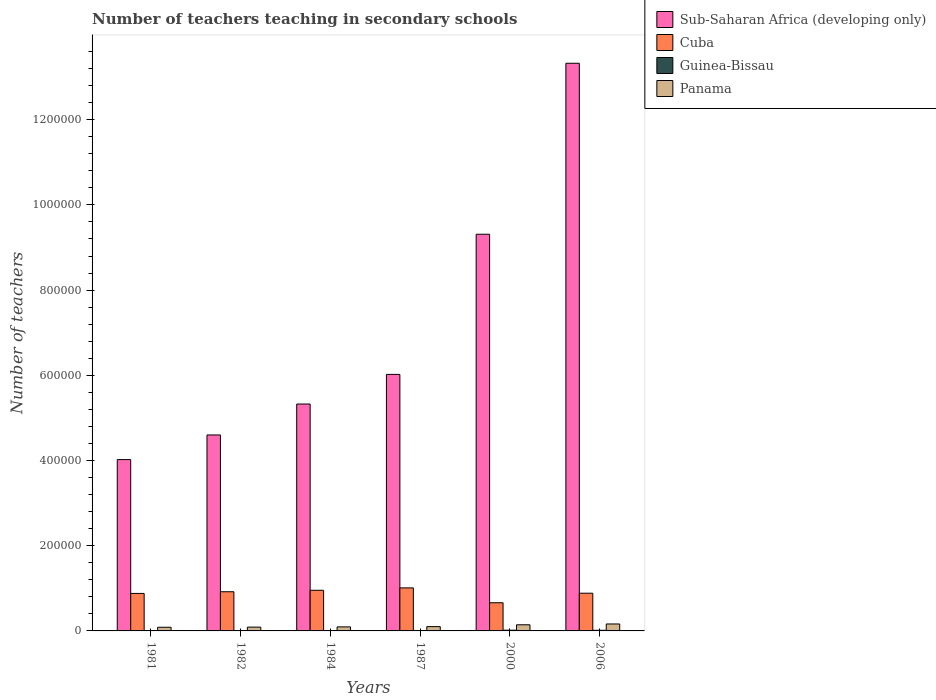How many different coloured bars are there?
Your response must be concise. 4. How many groups of bars are there?
Keep it short and to the point. 6. Are the number of bars on each tick of the X-axis equal?
Offer a terse response. Yes. How many bars are there on the 2nd tick from the left?
Ensure brevity in your answer.  4. In how many cases, is the number of bars for a given year not equal to the number of legend labels?
Ensure brevity in your answer.  0. What is the number of teachers teaching in secondary schools in Sub-Saharan Africa (developing only) in 1984?
Provide a succinct answer. 5.33e+05. Across all years, what is the maximum number of teachers teaching in secondary schools in Sub-Saharan Africa (developing only)?
Ensure brevity in your answer.  1.33e+06. Across all years, what is the minimum number of teachers teaching in secondary schools in Sub-Saharan Africa (developing only)?
Your answer should be very brief. 4.02e+05. What is the total number of teachers teaching in secondary schools in Sub-Saharan Africa (developing only) in the graph?
Provide a short and direct response. 4.26e+06. What is the difference between the number of teachers teaching in secondary schools in Guinea-Bissau in 1987 and that in 2000?
Provide a succinct answer. -953. What is the difference between the number of teachers teaching in secondary schools in Guinea-Bissau in 1981 and the number of teachers teaching in secondary schools in Cuba in 2000?
Your response must be concise. -6.57e+04. What is the average number of teachers teaching in secondary schools in Panama per year?
Your answer should be very brief. 1.13e+04. In the year 2000, what is the difference between the number of teachers teaching in secondary schools in Panama and number of teachers teaching in secondary schools in Guinea-Bissau?
Offer a very short reply. 1.27e+04. What is the ratio of the number of teachers teaching in secondary schools in Cuba in 1981 to that in 2000?
Make the answer very short. 1.33. What is the difference between the highest and the second highest number of teachers teaching in secondary schools in Sub-Saharan Africa (developing only)?
Offer a terse response. 4.01e+05. What is the difference between the highest and the lowest number of teachers teaching in secondary schools in Guinea-Bissau?
Make the answer very short. 1255. In how many years, is the number of teachers teaching in secondary schools in Sub-Saharan Africa (developing only) greater than the average number of teachers teaching in secondary schools in Sub-Saharan Africa (developing only) taken over all years?
Your response must be concise. 2. What does the 1st bar from the left in 2000 represents?
Provide a succinct answer. Sub-Saharan Africa (developing only). What does the 2nd bar from the right in 1982 represents?
Ensure brevity in your answer.  Guinea-Bissau. How many bars are there?
Ensure brevity in your answer.  24. Are all the bars in the graph horizontal?
Provide a short and direct response. No. How many years are there in the graph?
Provide a short and direct response. 6. Are the values on the major ticks of Y-axis written in scientific E-notation?
Offer a very short reply. No. Does the graph contain any zero values?
Provide a succinct answer. No. What is the title of the graph?
Your answer should be very brief. Number of teachers teaching in secondary schools. What is the label or title of the Y-axis?
Offer a very short reply. Number of teachers. What is the Number of teachers in Sub-Saharan Africa (developing only) in 1981?
Your answer should be very brief. 4.02e+05. What is the Number of teachers in Cuba in 1981?
Your answer should be very brief. 8.80e+04. What is the Number of teachers of Guinea-Bissau in 1981?
Offer a terse response. 462. What is the Number of teachers of Panama in 1981?
Give a very brief answer. 8610. What is the Number of teachers of Sub-Saharan Africa (developing only) in 1982?
Your answer should be compact. 4.60e+05. What is the Number of teachers in Cuba in 1982?
Make the answer very short. 9.20e+04. What is the Number of teachers of Guinea-Bissau in 1982?
Your answer should be very brief. 465. What is the Number of teachers in Panama in 1982?
Your response must be concise. 8924. What is the Number of teachers of Sub-Saharan Africa (developing only) in 1984?
Your answer should be very brief. 5.33e+05. What is the Number of teachers of Cuba in 1984?
Your answer should be very brief. 9.54e+04. What is the Number of teachers in Guinea-Bissau in 1984?
Your answer should be very brief. 795. What is the Number of teachers in Panama in 1984?
Give a very brief answer. 9491. What is the Number of teachers in Sub-Saharan Africa (developing only) in 1987?
Your answer should be very brief. 6.02e+05. What is the Number of teachers of Cuba in 1987?
Keep it short and to the point. 1.01e+05. What is the Number of teachers of Guinea-Bissau in 1987?
Ensure brevity in your answer.  764. What is the Number of teachers in Panama in 1987?
Offer a very short reply. 1.01e+04. What is the Number of teachers in Sub-Saharan Africa (developing only) in 2000?
Your answer should be very brief. 9.31e+05. What is the Number of teachers of Cuba in 2000?
Ensure brevity in your answer.  6.61e+04. What is the Number of teachers of Guinea-Bissau in 2000?
Make the answer very short. 1717. What is the Number of teachers in Panama in 2000?
Make the answer very short. 1.44e+04. What is the Number of teachers of Sub-Saharan Africa (developing only) in 2006?
Offer a terse response. 1.33e+06. What is the Number of teachers in Cuba in 2006?
Offer a terse response. 8.85e+04. What is the Number of teachers in Guinea-Bissau in 2006?
Your answer should be compact. 1480. What is the Number of teachers in Panama in 2006?
Your answer should be compact. 1.63e+04. Across all years, what is the maximum Number of teachers in Sub-Saharan Africa (developing only)?
Your answer should be very brief. 1.33e+06. Across all years, what is the maximum Number of teachers of Cuba?
Provide a short and direct response. 1.01e+05. Across all years, what is the maximum Number of teachers in Guinea-Bissau?
Your answer should be compact. 1717. Across all years, what is the maximum Number of teachers of Panama?
Ensure brevity in your answer.  1.63e+04. Across all years, what is the minimum Number of teachers in Sub-Saharan Africa (developing only)?
Offer a terse response. 4.02e+05. Across all years, what is the minimum Number of teachers of Cuba?
Your answer should be compact. 6.61e+04. Across all years, what is the minimum Number of teachers in Guinea-Bissau?
Your answer should be very brief. 462. Across all years, what is the minimum Number of teachers of Panama?
Give a very brief answer. 8610. What is the total Number of teachers of Sub-Saharan Africa (developing only) in the graph?
Offer a very short reply. 4.26e+06. What is the total Number of teachers of Cuba in the graph?
Provide a short and direct response. 5.31e+05. What is the total Number of teachers of Guinea-Bissau in the graph?
Offer a very short reply. 5683. What is the total Number of teachers in Panama in the graph?
Offer a very short reply. 6.78e+04. What is the difference between the Number of teachers in Sub-Saharan Africa (developing only) in 1981 and that in 1982?
Offer a terse response. -5.78e+04. What is the difference between the Number of teachers of Cuba in 1981 and that in 1982?
Keep it short and to the point. -3943. What is the difference between the Number of teachers of Guinea-Bissau in 1981 and that in 1982?
Ensure brevity in your answer.  -3. What is the difference between the Number of teachers of Panama in 1981 and that in 1982?
Offer a terse response. -314. What is the difference between the Number of teachers in Sub-Saharan Africa (developing only) in 1981 and that in 1984?
Make the answer very short. -1.30e+05. What is the difference between the Number of teachers of Cuba in 1981 and that in 1984?
Provide a short and direct response. -7377. What is the difference between the Number of teachers in Guinea-Bissau in 1981 and that in 1984?
Your answer should be compact. -333. What is the difference between the Number of teachers in Panama in 1981 and that in 1984?
Ensure brevity in your answer.  -881. What is the difference between the Number of teachers of Sub-Saharan Africa (developing only) in 1981 and that in 1987?
Make the answer very short. -2.00e+05. What is the difference between the Number of teachers in Cuba in 1981 and that in 1987?
Your response must be concise. -1.30e+04. What is the difference between the Number of teachers of Guinea-Bissau in 1981 and that in 1987?
Your answer should be very brief. -302. What is the difference between the Number of teachers of Panama in 1981 and that in 1987?
Your answer should be very brief. -1458. What is the difference between the Number of teachers of Sub-Saharan Africa (developing only) in 1981 and that in 2000?
Ensure brevity in your answer.  -5.29e+05. What is the difference between the Number of teachers in Cuba in 1981 and that in 2000?
Your response must be concise. 2.19e+04. What is the difference between the Number of teachers of Guinea-Bissau in 1981 and that in 2000?
Your response must be concise. -1255. What is the difference between the Number of teachers of Panama in 1981 and that in 2000?
Your answer should be compact. -5794. What is the difference between the Number of teachers of Sub-Saharan Africa (developing only) in 1981 and that in 2006?
Provide a short and direct response. -9.30e+05. What is the difference between the Number of teachers of Cuba in 1981 and that in 2006?
Your answer should be compact. -519. What is the difference between the Number of teachers in Guinea-Bissau in 1981 and that in 2006?
Offer a very short reply. -1018. What is the difference between the Number of teachers in Panama in 1981 and that in 2006?
Give a very brief answer. -7707. What is the difference between the Number of teachers in Sub-Saharan Africa (developing only) in 1982 and that in 1984?
Provide a succinct answer. -7.27e+04. What is the difference between the Number of teachers in Cuba in 1982 and that in 1984?
Keep it short and to the point. -3434. What is the difference between the Number of teachers in Guinea-Bissau in 1982 and that in 1984?
Your response must be concise. -330. What is the difference between the Number of teachers of Panama in 1982 and that in 1984?
Provide a short and direct response. -567. What is the difference between the Number of teachers in Sub-Saharan Africa (developing only) in 1982 and that in 1987?
Keep it short and to the point. -1.42e+05. What is the difference between the Number of teachers in Cuba in 1982 and that in 1987?
Keep it short and to the point. -9062. What is the difference between the Number of teachers in Guinea-Bissau in 1982 and that in 1987?
Offer a terse response. -299. What is the difference between the Number of teachers in Panama in 1982 and that in 1987?
Your response must be concise. -1144. What is the difference between the Number of teachers in Sub-Saharan Africa (developing only) in 1982 and that in 2000?
Your answer should be very brief. -4.71e+05. What is the difference between the Number of teachers in Cuba in 1982 and that in 2000?
Your answer should be very brief. 2.58e+04. What is the difference between the Number of teachers in Guinea-Bissau in 1982 and that in 2000?
Keep it short and to the point. -1252. What is the difference between the Number of teachers in Panama in 1982 and that in 2000?
Provide a succinct answer. -5480. What is the difference between the Number of teachers of Sub-Saharan Africa (developing only) in 1982 and that in 2006?
Provide a short and direct response. -8.73e+05. What is the difference between the Number of teachers in Cuba in 1982 and that in 2006?
Ensure brevity in your answer.  3424. What is the difference between the Number of teachers in Guinea-Bissau in 1982 and that in 2006?
Make the answer very short. -1015. What is the difference between the Number of teachers of Panama in 1982 and that in 2006?
Your answer should be compact. -7393. What is the difference between the Number of teachers of Sub-Saharan Africa (developing only) in 1984 and that in 1987?
Give a very brief answer. -6.95e+04. What is the difference between the Number of teachers in Cuba in 1984 and that in 1987?
Keep it short and to the point. -5628. What is the difference between the Number of teachers of Guinea-Bissau in 1984 and that in 1987?
Offer a very short reply. 31. What is the difference between the Number of teachers of Panama in 1984 and that in 1987?
Give a very brief answer. -577. What is the difference between the Number of teachers of Sub-Saharan Africa (developing only) in 1984 and that in 2000?
Your answer should be very brief. -3.99e+05. What is the difference between the Number of teachers of Cuba in 1984 and that in 2000?
Your answer should be compact. 2.93e+04. What is the difference between the Number of teachers of Guinea-Bissau in 1984 and that in 2000?
Keep it short and to the point. -922. What is the difference between the Number of teachers in Panama in 1984 and that in 2000?
Your answer should be compact. -4913. What is the difference between the Number of teachers of Sub-Saharan Africa (developing only) in 1984 and that in 2006?
Your response must be concise. -8.00e+05. What is the difference between the Number of teachers of Cuba in 1984 and that in 2006?
Your answer should be compact. 6858. What is the difference between the Number of teachers in Guinea-Bissau in 1984 and that in 2006?
Keep it short and to the point. -685. What is the difference between the Number of teachers in Panama in 1984 and that in 2006?
Your answer should be very brief. -6826. What is the difference between the Number of teachers of Sub-Saharan Africa (developing only) in 1987 and that in 2000?
Give a very brief answer. -3.29e+05. What is the difference between the Number of teachers of Cuba in 1987 and that in 2000?
Offer a terse response. 3.49e+04. What is the difference between the Number of teachers in Guinea-Bissau in 1987 and that in 2000?
Keep it short and to the point. -953. What is the difference between the Number of teachers of Panama in 1987 and that in 2000?
Give a very brief answer. -4336. What is the difference between the Number of teachers in Sub-Saharan Africa (developing only) in 1987 and that in 2006?
Ensure brevity in your answer.  -7.30e+05. What is the difference between the Number of teachers of Cuba in 1987 and that in 2006?
Give a very brief answer. 1.25e+04. What is the difference between the Number of teachers in Guinea-Bissau in 1987 and that in 2006?
Provide a short and direct response. -716. What is the difference between the Number of teachers in Panama in 1987 and that in 2006?
Your response must be concise. -6249. What is the difference between the Number of teachers of Sub-Saharan Africa (developing only) in 2000 and that in 2006?
Ensure brevity in your answer.  -4.01e+05. What is the difference between the Number of teachers of Cuba in 2000 and that in 2006?
Your answer should be compact. -2.24e+04. What is the difference between the Number of teachers of Guinea-Bissau in 2000 and that in 2006?
Make the answer very short. 237. What is the difference between the Number of teachers of Panama in 2000 and that in 2006?
Keep it short and to the point. -1913. What is the difference between the Number of teachers of Sub-Saharan Africa (developing only) in 1981 and the Number of teachers of Cuba in 1982?
Your response must be concise. 3.10e+05. What is the difference between the Number of teachers in Sub-Saharan Africa (developing only) in 1981 and the Number of teachers in Guinea-Bissau in 1982?
Your answer should be very brief. 4.02e+05. What is the difference between the Number of teachers in Sub-Saharan Africa (developing only) in 1981 and the Number of teachers in Panama in 1982?
Offer a terse response. 3.93e+05. What is the difference between the Number of teachers of Cuba in 1981 and the Number of teachers of Guinea-Bissau in 1982?
Ensure brevity in your answer.  8.76e+04. What is the difference between the Number of teachers in Cuba in 1981 and the Number of teachers in Panama in 1982?
Give a very brief answer. 7.91e+04. What is the difference between the Number of teachers in Guinea-Bissau in 1981 and the Number of teachers in Panama in 1982?
Offer a very short reply. -8462. What is the difference between the Number of teachers of Sub-Saharan Africa (developing only) in 1981 and the Number of teachers of Cuba in 1984?
Offer a terse response. 3.07e+05. What is the difference between the Number of teachers in Sub-Saharan Africa (developing only) in 1981 and the Number of teachers in Guinea-Bissau in 1984?
Your answer should be compact. 4.01e+05. What is the difference between the Number of teachers of Sub-Saharan Africa (developing only) in 1981 and the Number of teachers of Panama in 1984?
Your answer should be compact. 3.93e+05. What is the difference between the Number of teachers of Cuba in 1981 and the Number of teachers of Guinea-Bissau in 1984?
Provide a succinct answer. 8.72e+04. What is the difference between the Number of teachers in Cuba in 1981 and the Number of teachers in Panama in 1984?
Make the answer very short. 7.85e+04. What is the difference between the Number of teachers of Guinea-Bissau in 1981 and the Number of teachers of Panama in 1984?
Your answer should be compact. -9029. What is the difference between the Number of teachers in Sub-Saharan Africa (developing only) in 1981 and the Number of teachers in Cuba in 1987?
Your response must be concise. 3.01e+05. What is the difference between the Number of teachers of Sub-Saharan Africa (developing only) in 1981 and the Number of teachers of Guinea-Bissau in 1987?
Offer a terse response. 4.01e+05. What is the difference between the Number of teachers of Sub-Saharan Africa (developing only) in 1981 and the Number of teachers of Panama in 1987?
Provide a succinct answer. 3.92e+05. What is the difference between the Number of teachers in Cuba in 1981 and the Number of teachers in Guinea-Bissau in 1987?
Ensure brevity in your answer.  8.73e+04. What is the difference between the Number of teachers of Cuba in 1981 and the Number of teachers of Panama in 1987?
Make the answer very short. 7.79e+04. What is the difference between the Number of teachers of Guinea-Bissau in 1981 and the Number of teachers of Panama in 1987?
Make the answer very short. -9606. What is the difference between the Number of teachers in Sub-Saharan Africa (developing only) in 1981 and the Number of teachers in Cuba in 2000?
Your response must be concise. 3.36e+05. What is the difference between the Number of teachers of Sub-Saharan Africa (developing only) in 1981 and the Number of teachers of Guinea-Bissau in 2000?
Ensure brevity in your answer.  4.00e+05. What is the difference between the Number of teachers in Sub-Saharan Africa (developing only) in 1981 and the Number of teachers in Panama in 2000?
Provide a succinct answer. 3.88e+05. What is the difference between the Number of teachers in Cuba in 1981 and the Number of teachers in Guinea-Bissau in 2000?
Make the answer very short. 8.63e+04. What is the difference between the Number of teachers in Cuba in 1981 and the Number of teachers in Panama in 2000?
Make the answer very short. 7.36e+04. What is the difference between the Number of teachers in Guinea-Bissau in 1981 and the Number of teachers in Panama in 2000?
Give a very brief answer. -1.39e+04. What is the difference between the Number of teachers of Sub-Saharan Africa (developing only) in 1981 and the Number of teachers of Cuba in 2006?
Give a very brief answer. 3.14e+05. What is the difference between the Number of teachers in Sub-Saharan Africa (developing only) in 1981 and the Number of teachers in Guinea-Bissau in 2006?
Ensure brevity in your answer.  4.01e+05. What is the difference between the Number of teachers in Sub-Saharan Africa (developing only) in 1981 and the Number of teachers in Panama in 2006?
Ensure brevity in your answer.  3.86e+05. What is the difference between the Number of teachers of Cuba in 1981 and the Number of teachers of Guinea-Bissau in 2006?
Your answer should be very brief. 8.65e+04. What is the difference between the Number of teachers of Cuba in 1981 and the Number of teachers of Panama in 2006?
Your response must be concise. 7.17e+04. What is the difference between the Number of teachers of Guinea-Bissau in 1981 and the Number of teachers of Panama in 2006?
Offer a very short reply. -1.59e+04. What is the difference between the Number of teachers in Sub-Saharan Africa (developing only) in 1982 and the Number of teachers in Cuba in 1984?
Make the answer very short. 3.65e+05. What is the difference between the Number of teachers of Sub-Saharan Africa (developing only) in 1982 and the Number of teachers of Guinea-Bissau in 1984?
Offer a very short reply. 4.59e+05. What is the difference between the Number of teachers in Sub-Saharan Africa (developing only) in 1982 and the Number of teachers in Panama in 1984?
Offer a terse response. 4.50e+05. What is the difference between the Number of teachers in Cuba in 1982 and the Number of teachers in Guinea-Bissau in 1984?
Ensure brevity in your answer.  9.12e+04. What is the difference between the Number of teachers in Cuba in 1982 and the Number of teachers in Panama in 1984?
Offer a terse response. 8.25e+04. What is the difference between the Number of teachers of Guinea-Bissau in 1982 and the Number of teachers of Panama in 1984?
Give a very brief answer. -9026. What is the difference between the Number of teachers of Sub-Saharan Africa (developing only) in 1982 and the Number of teachers of Cuba in 1987?
Provide a short and direct response. 3.59e+05. What is the difference between the Number of teachers of Sub-Saharan Africa (developing only) in 1982 and the Number of teachers of Guinea-Bissau in 1987?
Your response must be concise. 4.59e+05. What is the difference between the Number of teachers of Sub-Saharan Africa (developing only) in 1982 and the Number of teachers of Panama in 1987?
Provide a short and direct response. 4.50e+05. What is the difference between the Number of teachers in Cuba in 1982 and the Number of teachers in Guinea-Bissau in 1987?
Your answer should be very brief. 9.12e+04. What is the difference between the Number of teachers of Cuba in 1982 and the Number of teachers of Panama in 1987?
Your answer should be very brief. 8.19e+04. What is the difference between the Number of teachers of Guinea-Bissau in 1982 and the Number of teachers of Panama in 1987?
Offer a terse response. -9603. What is the difference between the Number of teachers of Sub-Saharan Africa (developing only) in 1982 and the Number of teachers of Cuba in 2000?
Your response must be concise. 3.94e+05. What is the difference between the Number of teachers in Sub-Saharan Africa (developing only) in 1982 and the Number of teachers in Guinea-Bissau in 2000?
Provide a succinct answer. 4.58e+05. What is the difference between the Number of teachers in Sub-Saharan Africa (developing only) in 1982 and the Number of teachers in Panama in 2000?
Your answer should be very brief. 4.46e+05. What is the difference between the Number of teachers in Cuba in 1982 and the Number of teachers in Guinea-Bissau in 2000?
Your response must be concise. 9.02e+04. What is the difference between the Number of teachers in Cuba in 1982 and the Number of teachers in Panama in 2000?
Keep it short and to the point. 7.76e+04. What is the difference between the Number of teachers in Guinea-Bissau in 1982 and the Number of teachers in Panama in 2000?
Provide a succinct answer. -1.39e+04. What is the difference between the Number of teachers of Sub-Saharan Africa (developing only) in 1982 and the Number of teachers of Cuba in 2006?
Your response must be concise. 3.71e+05. What is the difference between the Number of teachers of Sub-Saharan Africa (developing only) in 1982 and the Number of teachers of Guinea-Bissau in 2006?
Provide a succinct answer. 4.58e+05. What is the difference between the Number of teachers of Sub-Saharan Africa (developing only) in 1982 and the Number of teachers of Panama in 2006?
Keep it short and to the point. 4.44e+05. What is the difference between the Number of teachers in Cuba in 1982 and the Number of teachers in Guinea-Bissau in 2006?
Ensure brevity in your answer.  9.05e+04. What is the difference between the Number of teachers of Cuba in 1982 and the Number of teachers of Panama in 2006?
Give a very brief answer. 7.56e+04. What is the difference between the Number of teachers in Guinea-Bissau in 1982 and the Number of teachers in Panama in 2006?
Your answer should be compact. -1.59e+04. What is the difference between the Number of teachers in Sub-Saharan Africa (developing only) in 1984 and the Number of teachers in Cuba in 1987?
Offer a terse response. 4.32e+05. What is the difference between the Number of teachers of Sub-Saharan Africa (developing only) in 1984 and the Number of teachers of Guinea-Bissau in 1987?
Your response must be concise. 5.32e+05. What is the difference between the Number of teachers of Sub-Saharan Africa (developing only) in 1984 and the Number of teachers of Panama in 1987?
Offer a terse response. 5.23e+05. What is the difference between the Number of teachers in Cuba in 1984 and the Number of teachers in Guinea-Bissau in 1987?
Keep it short and to the point. 9.46e+04. What is the difference between the Number of teachers in Cuba in 1984 and the Number of teachers in Panama in 1987?
Your answer should be very brief. 8.53e+04. What is the difference between the Number of teachers of Guinea-Bissau in 1984 and the Number of teachers of Panama in 1987?
Your answer should be very brief. -9273. What is the difference between the Number of teachers of Sub-Saharan Africa (developing only) in 1984 and the Number of teachers of Cuba in 2000?
Ensure brevity in your answer.  4.66e+05. What is the difference between the Number of teachers of Sub-Saharan Africa (developing only) in 1984 and the Number of teachers of Guinea-Bissau in 2000?
Give a very brief answer. 5.31e+05. What is the difference between the Number of teachers in Sub-Saharan Africa (developing only) in 1984 and the Number of teachers in Panama in 2000?
Provide a short and direct response. 5.18e+05. What is the difference between the Number of teachers of Cuba in 1984 and the Number of teachers of Guinea-Bissau in 2000?
Your answer should be very brief. 9.37e+04. What is the difference between the Number of teachers in Cuba in 1984 and the Number of teachers in Panama in 2000?
Make the answer very short. 8.10e+04. What is the difference between the Number of teachers in Guinea-Bissau in 1984 and the Number of teachers in Panama in 2000?
Keep it short and to the point. -1.36e+04. What is the difference between the Number of teachers in Sub-Saharan Africa (developing only) in 1984 and the Number of teachers in Cuba in 2006?
Make the answer very short. 4.44e+05. What is the difference between the Number of teachers in Sub-Saharan Africa (developing only) in 1984 and the Number of teachers in Guinea-Bissau in 2006?
Your answer should be very brief. 5.31e+05. What is the difference between the Number of teachers in Sub-Saharan Africa (developing only) in 1984 and the Number of teachers in Panama in 2006?
Offer a terse response. 5.16e+05. What is the difference between the Number of teachers of Cuba in 1984 and the Number of teachers of Guinea-Bissau in 2006?
Give a very brief answer. 9.39e+04. What is the difference between the Number of teachers in Cuba in 1984 and the Number of teachers in Panama in 2006?
Offer a terse response. 7.91e+04. What is the difference between the Number of teachers of Guinea-Bissau in 1984 and the Number of teachers of Panama in 2006?
Offer a very short reply. -1.55e+04. What is the difference between the Number of teachers of Sub-Saharan Africa (developing only) in 1987 and the Number of teachers of Cuba in 2000?
Your response must be concise. 5.36e+05. What is the difference between the Number of teachers in Sub-Saharan Africa (developing only) in 1987 and the Number of teachers in Guinea-Bissau in 2000?
Offer a terse response. 6.00e+05. What is the difference between the Number of teachers in Sub-Saharan Africa (developing only) in 1987 and the Number of teachers in Panama in 2000?
Your answer should be compact. 5.88e+05. What is the difference between the Number of teachers of Cuba in 1987 and the Number of teachers of Guinea-Bissau in 2000?
Your answer should be very brief. 9.93e+04. What is the difference between the Number of teachers of Cuba in 1987 and the Number of teachers of Panama in 2000?
Your answer should be very brief. 8.66e+04. What is the difference between the Number of teachers in Guinea-Bissau in 1987 and the Number of teachers in Panama in 2000?
Keep it short and to the point. -1.36e+04. What is the difference between the Number of teachers in Sub-Saharan Africa (developing only) in 1987 and the Number of teachers in Cuba in 2006?
Keep it short and to the point. 5.14e+05. What is the difference between the Number of teachers of Sub-Saharan Africa (developing only) in 1987 and the Number of teachers of Guinea-Bissau in 2006?
Provide a short and direct response. 6.01e+05. What is the difference between the Number of teachers in Sub-Saharan Africa (developing only) in 1987 and the Number of teachers in Panama in 2006?
Keep it short and to the point. 5.86e+05. What is the difference between the Number of teachers of Cuba in 1987 and the Number of teachers of Guinea-Bissau in 2006?
Offer a very short reply. 9.95e+04. What is the difference between the Number of teachers of Cuba in 1987 and the Number of teachers of Panama in 2006?
Make the answer very short. 8.47e+04. What is the difference between the Number of teachers of Guinea-Bissau in 1987 and the Number of teachers of Panama in 2006?
Provide a succinct answer. -1.56e+04. What is the difference between the Number of teachers in Sub-Saharan Africa (developing only) in 2000 and the Number of teachers in Cuba in 2006?
Your answer should be very brief. 8.43e+05. What is the difference between the Number of teachers in Sub-Saharan Africa (developing only) in 2000 and the Number of teachers in Guinea-Bissau in 2006?
Provide a short and direct response. 9.30e+05. What is the difference between the Number of teachers of Sub-Saharan Africa (developing only) in 2000 and the Number of teachers of Panama in 2006?
Offer a terse response. 9.15e+05. What is the difference between the Number of teachers in Cuba in 2000 and the Number of teachers in Guinea-Bissau in 2006?
Your response must be concise. 6.46e+04. What is the difference between the Number of teachers of Cuba in 2000 and the Number of teachers of Panama in 2006?
Ensure brevity in your answer.  4.98e+04. What is the difference between the Number of teachers of Guinea-Bissau in 2000 and the Number of teachers of Panama in 2006?
Keep it short and to the point. -1.46e+04. What is the average Number of teachers of Sub-Saharan Africa (developing only) per year?
Your answer should be very brief. 7.10e+05. What is the average Number of teachers of Cuba per year?
Your answer should be very brief. 8.85e+04. What is the average Number of teachers in Guinea-Bissau per year?
Provide a short and direct response. 947.17. What is the average Number of teachers in Panama per year?
Offer a terse response. 1.13e+04. In the year 1981, what is the difference between the Number of teachers in Sub-Saharan Africa (developing only) and Number of teachers in Cuba?
Offer a very short reply. 3.14e+05. In the year 1981, what is the difference between the Number of teachers of Sub-Saharan Africa (developing only) and Number of teachers of Guinea-Bissau?
Provide a short and direct response. 4.02e+05. In the year 1981, what is the difference between the Number of teachers in Sub-Saharan Africa (developing only) and Number of teachers in Panama?
Ensure brevity in your answer.  3.94e+05. In the year 1981, what is the difference between the Number of teachers of Cuba and Number of teachers of Guinea-Bissau?
Your answer should be compact. 8.76e+04. In the year 1981, what is the difference between the Number of teachers of Cuba and Number of teachers of Panama?
Provide a short and direct response. 7.94e+04. In the year 1981, what is the difference between the Number of teachers in Guinea-Bissau and Number of teachers in Panama?
Your answer should be very brief. -8148. In the year 1982, what is the difference between the Number of teachers of Sub-Saharan Africa (developing only) and Number of teachers of Cuba?
Make the answer very short. 3.68e+05. In the year 1982, what is the difference between the Number of teachers in Sub-Saharan Africa (developing only) and Number of teachers in Guinea-Bissau?
Provide a short and direct response. 4.59e+05. In the year 1982, what is the difference between the Number of teachers of Sub-Saharan Africa (developing only) and Number of teachers of Panama?
Provide a short and direct response. 4.51e+05. In the year 1982, what is the difference between the Number of teachers in Cuba and Number of teachers in Guinea-Bissau?
Ensure brevity in your answer.  9.15e+04. In the year 1982, what is the difference between the Number of teachers of Cuba and Number of teachers of Panama?
Ensure brevity in your answer.  8.30e+04. In the year 1982, what is the difference between the Number of teachers in Guinea-Bissau and Number of teachers in Panama?
Give a very brief answer. -8459. In the year 1984, what is the difference between the Number of teachers in Sub-Saharan Africa (developing only) and Number of teachers in Cuba?
Ensure brevity in your answer.  4.37e+05. In the year 1984, what is the difference between the Number of teachers in Sub-Saharan Africa (developing only) and Number of teachers in Guinea-Bissau?
Ensure brevity in your answer.  5.32e+05. In the year 1984, what is the difference between the Number of teachers in Sub-Saharan Africa (developing only) and Number of teachers in Panama?
Keep it short and to the point. 5.23e+05. In the year 1984, what is the difference between the Number of teachers of Cuba and Number of teachers of Guinea-Bissau?
Offer a very short reply. 9.46e+04. In the year 1984, what is the difference between the Number of teachers of Cuba and Number of teachers of Panama?
Ensure brevity in your answer.  8.59e+04. In the year 1984, what is the difference between the Number of teachers of Guinea-Bissau and Number of teachers of Panama?
Your response must be concise. -8696. In the year 1987, what is the difference between the Number of teachers of Sub-Saharan Africa (developing only) and Number of teachers of Cuba?
Offer a terse response. 5.01e+05. In the year 1987, what is the difference between the Number of teachers of Sub-Saharan Africa (developing only) and Number of teachers of Guinea-Bissau?
Provide a succinct answer. 6.01e+05. In the year 1987, what is the difference between the Number of teachers of Sub-Saharan Africa (developing only) and Number of teachers of Panama?
Offer a very short reply. 5.92e+05. In the year 1987, what is the difference between the Number of teachers of Cuba and Number of teachers of Guinea-Bissau?
Your answer should be compact. 1.00e+05. In the year 1987, what is the difference between the Number of teachers of Cuba and Number of teachers of Panama?
Your answer should be compact. 9.10e+04. In the year 1987, what is the difference between the Number of teachers in Guinea-Bissau and Number of teachers in Panama?
Your answer should be very brief. -9304. In the year 2000, what is the difference between the Number of teachers of Sub-Saharan Africa (developing only) and Number of teachers of Cuba?
Give a very brief answer. 8.65e+05. In the year 2000, what is the difference between the Number of teachers of Sub-Saharan Africa (developing only) and Number of teachers of Guinea-Bissau?
Your answer should be compact. 9.29e+05. In the year 2000, what is the difference between the Number of teachers of Sub-Saharan Africa (developing only) and Number of teachers of Panama?
Ensure brevity in your answer.  9.17e+05. In the year 2000, what is the difference between the Number of teachers in Cuba and Number of teachers in Guinea-Bissau?
Your response must be concise. 6.44e+04. In the year 2000, what is the difference between the Number of teachers of Cuba and Number of teachers of Panama?
Offer a terse response. 5.17e+04. In the year 2000, what is the difference between the Number of teachers in Guinea-Bissau and Number of teachers in Panama?
Keep it short and to the point. -1.27e+04. In the year 2006, what is the difference between the Number of teachers in Sub-Saharan Africa (developing only) and Number of teachers in Cuba?
Keep it short and to the point. 1.24e+06. In the year 2006, what is the difference between the Number of teachers in Sub-Saharan Africa (developing only) and Number of teachers in Guinea-Bissau?
Make the answer very short. 1.33e+06. In the year 2006, what is the difference between the Number of teachers in Sub-Saharan Africa (developing only) and Number of teachers in Panama?
Your response must be concise. 1.32e+06. In the year 2006, what is the difference between the Number of teachers in Cuba and Number of teachers in Guinea-Bissau?
Keep it short and to the point. 8.71e+04. In the year 2006, what is the difference between the Number of teachers in Cuba and Number of teachers in Panama?
Offer a very short reply. 7.22e+04. In the year 2006, what is the difference between the Number of teachers in Guinea-Bissau and Number of teachers in Panama?
Your answer should be very brief. -1.48e+04. What is the ratio of the Number of teachers of Sub-Saharan Africa (developing only) in 1981 to that in 1982?
Make the answer very short. 0.87. What is the ratio of the Number of teachers of Cuba in 1981 to that in 1982?
Ensure brevity in your answer.  0.96. What is the ratio of the Number of teachers in Panama in 1981 to that in 1982?
Offer a terse response. 0.96. What is the ratio of the Number of teachers in Sub-Saharan Africa (developing only) in 1981 to that in 1984?
Your answer should be very brief. 0.76. What is the ratio of the Number of teachers in Cuba in 1981 to that in 1984?
Your answer should be compact. 0.92. What is the ratio of the Number of teachers of Guinea-Bissau in 1981 to that in 1984?
Offer a terse response. 0.58. What is the ratio of the Number of teachers of Panama in 1981 to that in 1984?
Make the answer very short. 0.91. What is the ratio of the Number of teachers in Sub-Saharan Africa (developing only) in 1981 to that in 1987?
Provide a short and direct response. 0.67. What is the ratio of the Number of teachers of Cuba in 1981 to that in 1987?
Offer a terse response. 0.87. What is the ratio of the Number of teachers of Guinea-Bissau in 1981 to that in 1987?
Your answer should be compact. 0.6. What is the ratio of the Number of teachers of Panama in 1981 to that in 1987?
Provide a short and direct response. 0.86. What is the ratio of the Number of teachers of Sub-Saharan Africa (developing only) in 1981 to that in 2000?
Your answer should be compact. 0.43. What is the ratio of the Number of teachers in Cuba in 1981 to that in 2000?
Give a very brief answer. 1.33. What is the ratio of the Number of teachers of Guinea-Bissau in 1981 to that in 2000?
Your answer should be very brief. 0.27. What is the ratio of the Number of teachers in Panama in 1981 to that in 2000?
Give a very brief answer. 0.6. What is the ratio of the Number of teachers in Sub-Saharan Africa (developing only) in 1981 to that in 2006?
Provide a succinct answer. 0.3. What is the ratio of the Number of teachers of Guinea-Bissau in 1981 to that in 2006?
Your response must be concise. 0.31. What is the ratio of the Number of teachers in Panama in 1981 to that in 2006?
Offer a terse response. 0.53. What is the ratio of the Number of teachers of Sub-Saharan Africa (developing only) in 1982 to that in 1984?
Offer a very short reply. 0.86. What is the ratio of the Number of teachers of Cuba in 1982 to that in 1984?
Your answer should be very brief. 0.96. What is the ratio of the Number of teachers of Guinea-Bissau in 1982 to that in 1984?
Give a very brief answer. 0.58. What is the ratio of the Number of teachers of Panama in 1982 to that in 1984?
Your response must be concise. 0.94. What is the ratio of the Number of teachers in Sub-Saharan Africa (developing only) in 1982 to that in 1987?
Offer a very short reply. 0.76. What is the ratio of the Number of teachers in Cuba in 1982 to that in 1987?
Your answer should be compact. 0.91. What is the ratio of the Number of teachers in Guinea-Bissau in 1982 to that in 1987?
Offer a very short reply. 0.61. What is the ratio of the Number of teachers of Panama in 1982 to that in 1987?
Offer a terse response. 0.89. What is the ratio of the Number of teachers in Sub-Saharan Africa (developing only) in 1982 to that in 2000?
Offer a very short reply. 0.49. What is the ratio of the Number of teachers in Cuba in 1982 to that in 2000?
Provide a succinct answer. 1.39. What is the ratio of the Number of teachers in Guinea-Bissau in 1982 to that in 2000?
Give a very brief answer. 0.27. What is the ratio of the Number of teachers in Panama in 1982 to that in 2000?
Offer a very short reply. 0.62. What is the ratio of the Number of teachers in Sub-Saharan Africa (developing only) in 1982 to that in 2006?
Keep it short and to the point. 0.35. What is the ratio of the Number of teachers in Cuba in 1982 to that in 2006?
Offer a very short reply. 1.04. What is the ratio of the Number of teachers of Guinea-Bissau in 1982 to that in 2006?
Give a very brief answer. 0.31. What is the ratio of the Number of teachers in Panama in 1982 to that in 2006?
Keep it short and to the point. 0.55. What is the ratio of the Number of teachers in Sub-Saharan Africa (developing only) in 1984 to that in 1987?
Provide a short and direct response. 0.88. What is the ratio of the Number of teachers of Cuba in 1984 to that in 1987?
Give a very brief answer. 0.94. What is the ratio of the Number of teachers in Guinea-Bissau in 1984 to that in 1987?
Give a very brief answer. 1.04. What is the ratio of the Number of teachers in Panama in 1984 to that in 1987?
Your answer should be compact. 0.94. What is the ratio of the Number of teachers of Sub-Saharan Africa (developing only) in 1984 to that in 2000?
Keep it short and to the point. 0.57. What is the ratio of the Number of teachers in Cuba in 1984 to that in 2000?
Your answer should be compact. 1.44. What is the ratio of the Number of teachers of Guinea-Bissau in 1984 to that in 2000?
Ensure brevity in your answer.  0.46. What is the ratio of the Number of teachers in Panama in 1984 to that in 2000?
Provide a succinct answer. 0.66. What is the ratio of the Number of teachers in Sub-Saharan Africa (developing only) in 1984 to that in 2006?
Give a very brief answer. 0.4. What is the ratio of the Number of teachers of Cuba in 1984 to that in 2006?
Your answer should be very brief. 1.08. What is the ratio of the Number of teachers of Guinea-Bissau in 1984 to that in 2006?
Provide a succinct answer. 0.54. What is the ratio of the Number of teachers of Panama in 1984 to that in 2006?
Your response must be concise. 0.58. What is the ratio of the Number of teachers in Sub-Saharan Africa (developing only) in 1987 to that in 2000?
Offer a very short reply. 0.65. What is the ratio of the Number of teachers in Cuba in 1987 to that in 2000?
Provide a short and direct response. 1.53. What is the ratio of the Number of teachers of Guinea-Bissau in 1987 to that in 2000?
Ensure brevity in your answer.  0.45. What is the ratio of the Number of teachers of Panama in 1987 to that in 2000?
Ensure brevity in your answer.  0.7. What is the ratio of the Number of teachers of Sub-Saharan Africa (developing only) in 1987 to that in 2006?
Offer a very short reply. 0.45. What is the ratio of the Number of teachers of Cuba in 1987 to that in 2006?
Offer a terse response. 1.14. What is the ratio of the Number of teachers of Guinea-Bissau in 1987 to that in 2006?
Offer a terse response. 0.52. What is the ratio of the Number of teachers in Panama in 1987 to that in 2006?
Offer a very short reply. 0.62. What is the ratio of the Number of teachers in Sub-Saharan Africa (developing only) in 2000 to that in 2006?
Provide a short and direct response. 0.7. What is the ratio of the Number of teachers in Cuba in 2000 to that in 2006?
Give a very brief answer. 0.75. What is the ratio of the Number of teachers of Guinea-Bissau in 2000 to that in 2006?
Your answer should be compact. 1.16. What is the ratio of the Number of teachers in Panama in 2000 to that in 2006?
Your answer should be compact. 0.88. What is the difference between the highest and the second highest Number of teachers in Sub-Saharan Africa (developing only)?
Give a very brief answer. 4.01e+05. What is the difference between the highest and the second highest Number of teachers of Cuba?
Your answer should be compact. 5628. What is the difference between the highest and the second highest Number of teachers in Guinea-Bissau?
Make the answer very short. 237. What is the difference between the highest and the second highest Number of teachers of Panama?
Keep it short and to the point. 1913. What is the difference between the highest and the lowest Number of teachers of Sub-Saharan Africa (developing only)?
Your response must be concise. 9.30e+05. What is the difference between the highest and the lowest Number of teachers of Cuba?
Ensure brevity in your answer.  3.49e+04. What is the difference between the highest and the lowest Number of teachers of Guinea-Bissau?
Your answer should be very brief. 1255. What is the difference between the highest and the lowest Number of teachers of Panama?
Keep it short and to the point. 7707. 